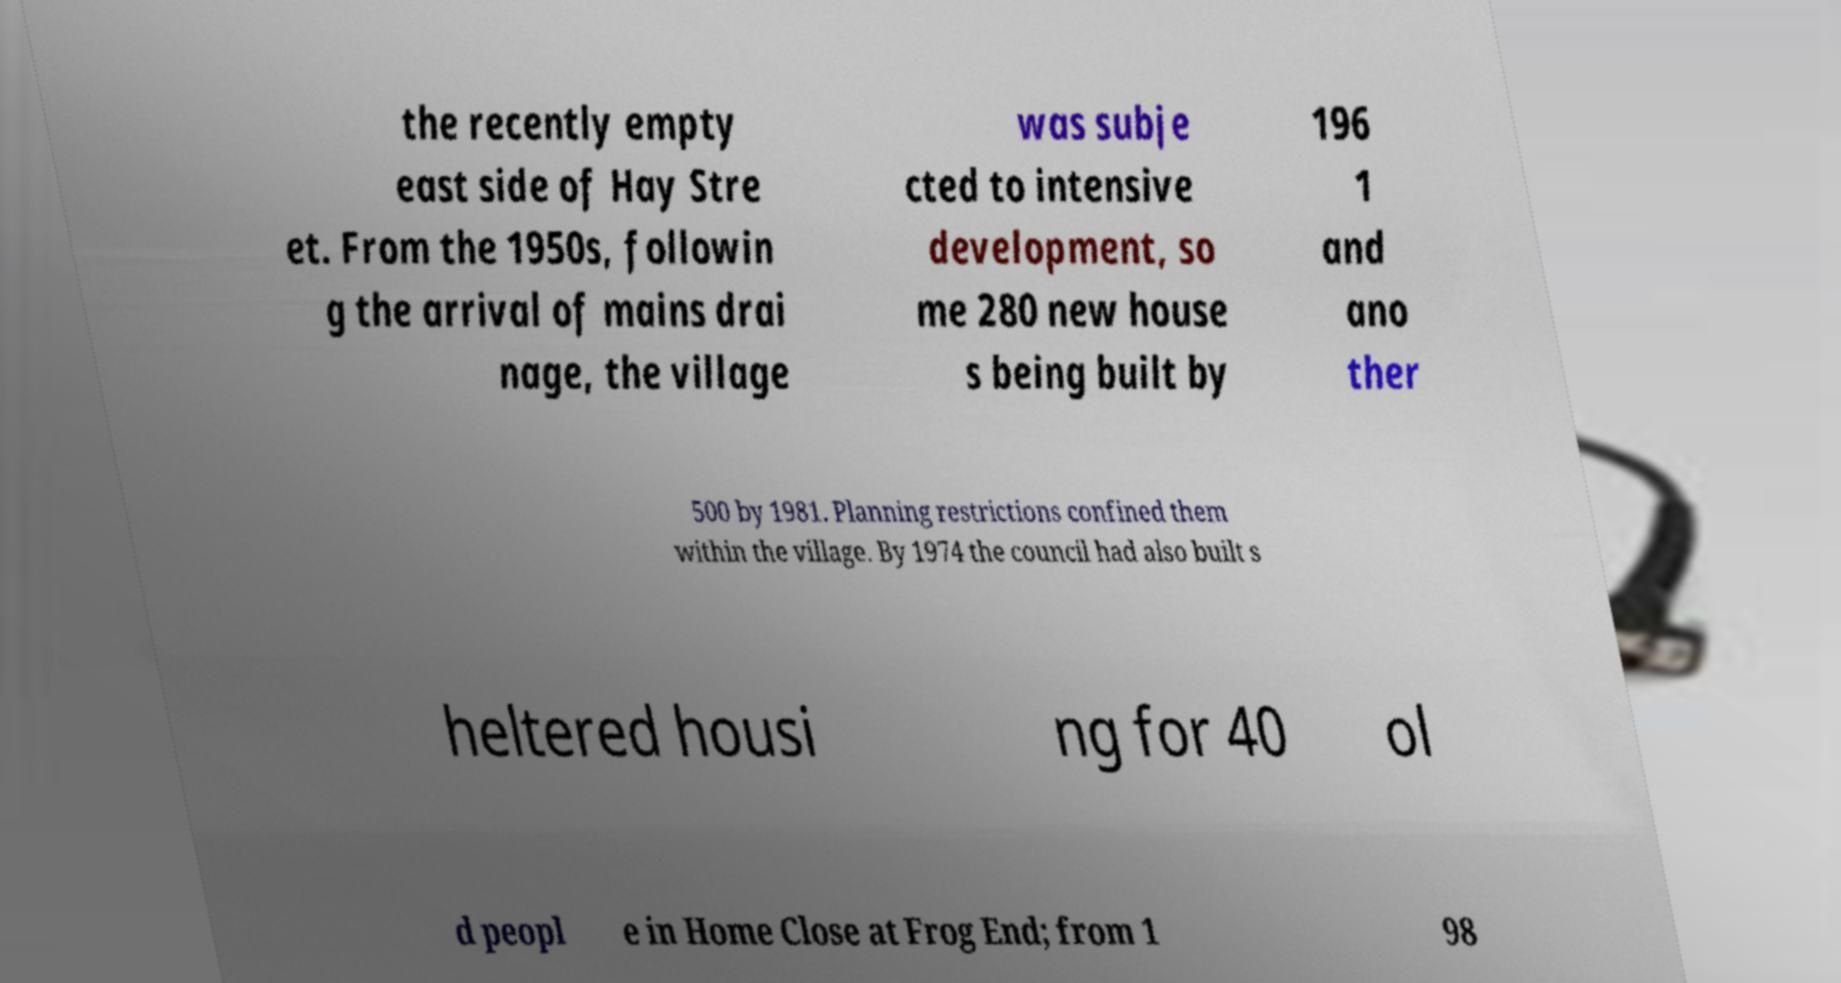Could you extract and type out the text from this image? the recently empty east side of Hay Stre et. From the 1950s, followin g the arrival of mains drai nage, the village was subje cted to intensive development, so me 280 new house s being built by 196 1 and ano ther 500 by 1981. Planning restrictions confined them within the village. By 1974 the council had also built s heltered housi ng for 40 ol d peopl e in Home Close at Frog End; from 1 98 